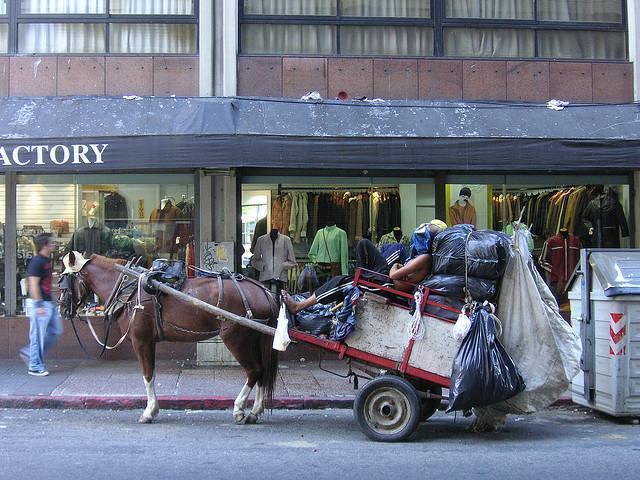What item here makes the horse go forward focusing?
Pick the correct solution from the four options below to address the question.
Options: Shoes, garbage bags, blinders, hat. Blinders. 